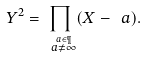<formula> <loc_0><loc_0><loc_500><loc_500>Y ^ { 2 } = \prod _ { \overset { \ a \in \P } { \ a \neq \infty } } ( X - \ a ) .</formula> 